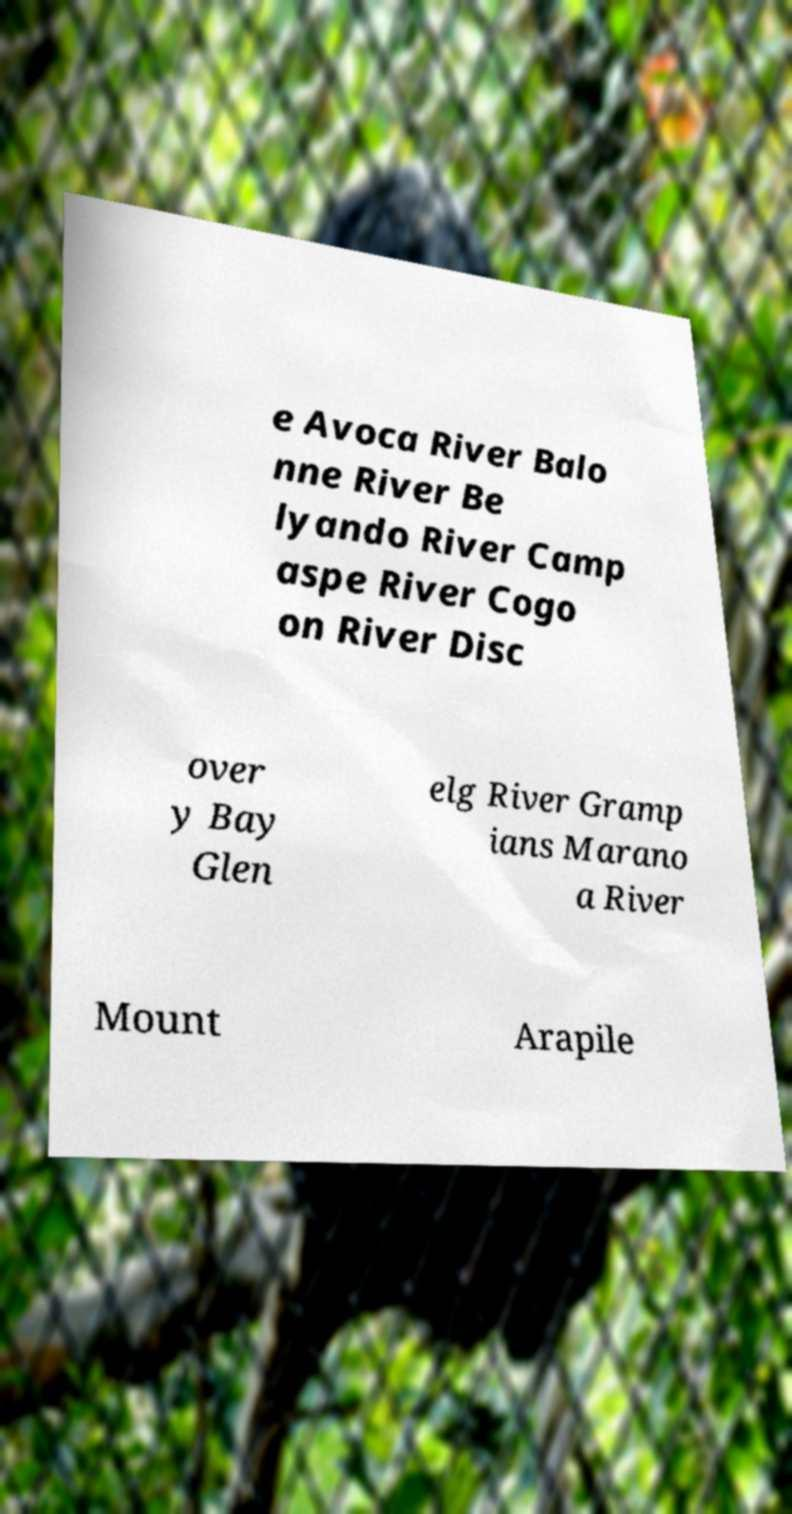What messages or text are displayed in this image? I need them in a readable, typed format. e Avoca River Balo nne River Be lyando River Camp aspe River Cogo on River Disc over y Bay Glen elg River Gramp ians Marano a River Mount Arapile 